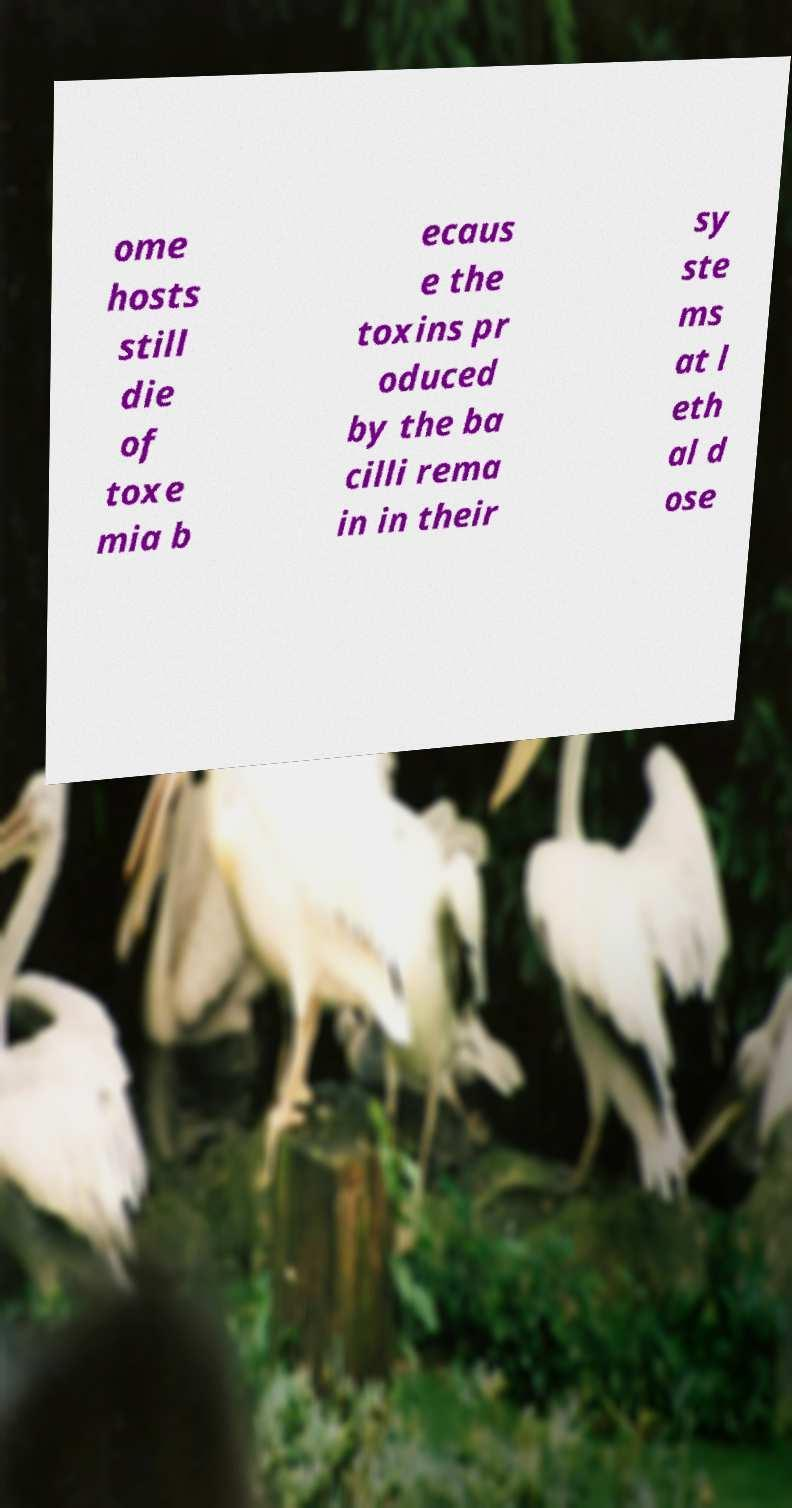What messages or text are displayed in this image? I need them in a readable, typed format. ome hosts still die of toxe mia b ecaus e the toxins pr oduced by the ba cilli rema in in their sy ste ms at l eth al d ose 